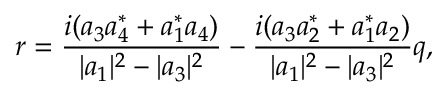Convert formula to latex. <formula><loc_0><loc_0><loc_500><loc_500>r = \frac { i ( a _ { 3 } a _ { 4 } ^ { * } + a _ { 1 } ^ { * } a _ { 4 } ) } { | a _ { 1 } | ^ { 2 } - | a _ { 3 } | ^ { 2 } } - \frac { i ( a _ { 3 } a _ { 2 } ^ { * } + a _ { 1 } ^ { * } a _ { 2 } ) } { | a _ { 1 } | ^ { 2 } - | a _ { 3 } | ^ { 2 } } q ,</formula> 